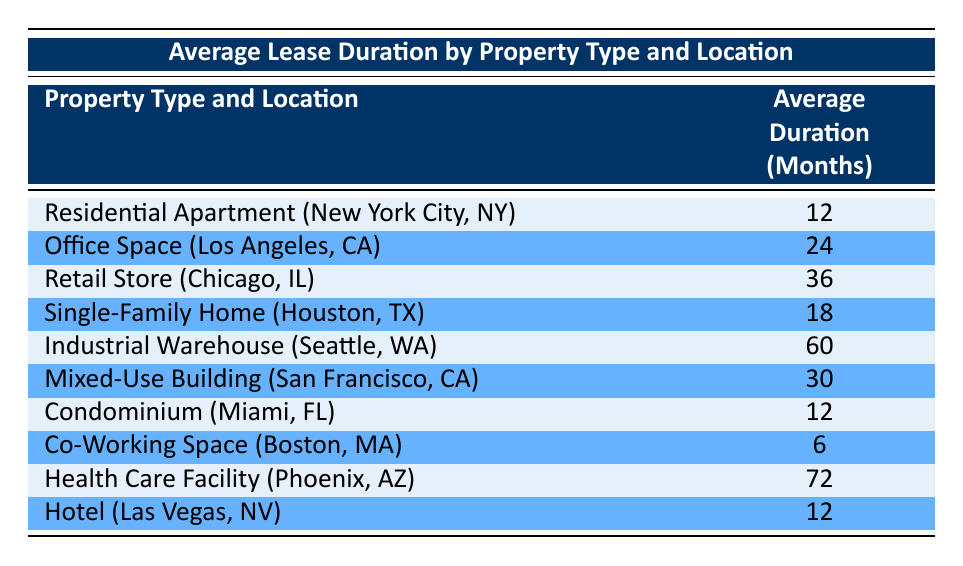What is the average lease duration for an Industrial Warehouse in Seattle, WA? According to the table, the Average Lease Duration for an Industrial Warehouse located in Seattle, WA is 60 months.
Answer: 60 months Which property type has the longest average lease duration? The Health Care Facility in Phoenix, AZ has the longest average lease duration at 72 months according to the table.
Answer: Health Care Facility Is the average lease duration for a Co-Working Space longer than a Residential Apartment? The Co-Working Space has an average lease duration of 6 months, while the Residential Apartment has an average lease duration of 12 months. Since 6 is not longer than 12, the answer is no.
Answer: No What is the average lease duration for the Mixed-Use Building in San Francisco, CA? The table shows that the average lease duration for a Mixed-Use Building located in San Francisco, CA is 30 months.
Answer: 30 months Calculate the average lease duration of the properties located in California (Los Angeles, CA and San Francisco, CA). For Los Angeles, CA (Office Space) the average duration is 24 months, and for San Francisco, CA (Mixed-Use Building) it's 30 months. To find the average: (24 + 30) / 2 = 27 months.
Answer: 27 months Does any property type in the table have an average lease duration of exactly 12 months? The table lists three property types: Residential Apartment, Condominium, and Hotel, all having an average lease duration of 12 months. Therefore, the answer is yes.
Answer: Yes What is the difference in average lease duration between the Health Care Facility and the Co-Working Space? The Health Care Facility has an average duration of 72 months, while the Co-Working Space has 6 months. The difference is calculated as 72 - 6 = 66 months.
Answer: 66 months In which location does the Single-Family Home have an average lease duration, and what is that duration? The Single-Family Home has an average lease duration of 18 months located in Houston, TX according to the table.
Answer: Houston, TX; 18 months What is the average lease duration for properties in Florida? There are two properties in Florida: Condominium (12 months) and Hotel (12 months). The average lease duration is (12 + 12) / 2 = 12 months.
Answer: 12 months 